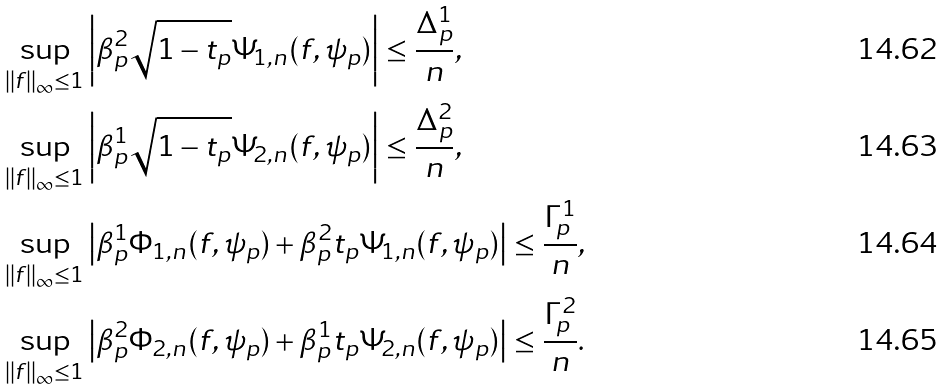Convert formula to latex. <formula><loc_0><loc_0><loc_500><loc_500>& \sup _ { \| f \| _ { \infty } \leq 1 } \left | \beta _ { p } ^ { 2 } \sqrt { 1 - t _ { p } } \Psi _ { 1 , n } ( f , \psi _ { p } ) \right | \leq \frac { \Delta _ { p } ^ { 1 } } { n } , \\ & \sup _ { \| f \| _ { \infty } \leq 1 } \left | \beta _ { p } ^ { 1 } \sqrt { 1 - t _ { p } } \Psi _ { 2 , n } ( f , \psi _ { p } ) \right | \leq \frac { \Delta _ { p } ^ { 2 } } { n } , \\ & \sup _ { \| f \| _ { \infty } \leq 1 } \left | \beta _ { p } ^ { 1 } \Phi _ { 1 , n } ( f , \psi _ { p } ) + \beta _ { p } ^ { 2 } { t _ { p } } \Psi _ { 1 , n } ( f , \psi _ { p } ) \right | \leq \frac { \Gamma _ { p } ^ { 1 } } { n } , \\ & \sup _ { \| f \| _ { \infty } \leq 1 } \left | \beta _ { p } ^ { 2 } \Phi _ { 2 , n } ( f , \psi _ { p } ) + \beta _ { p } ^ { 1 } { t _ { p } } \Psi _ { 2 , n } ( f , \psi _ { p } ) \right | \leq \frac { \Gamma _ { p } ^ { 2 } } { n } .</formula> 